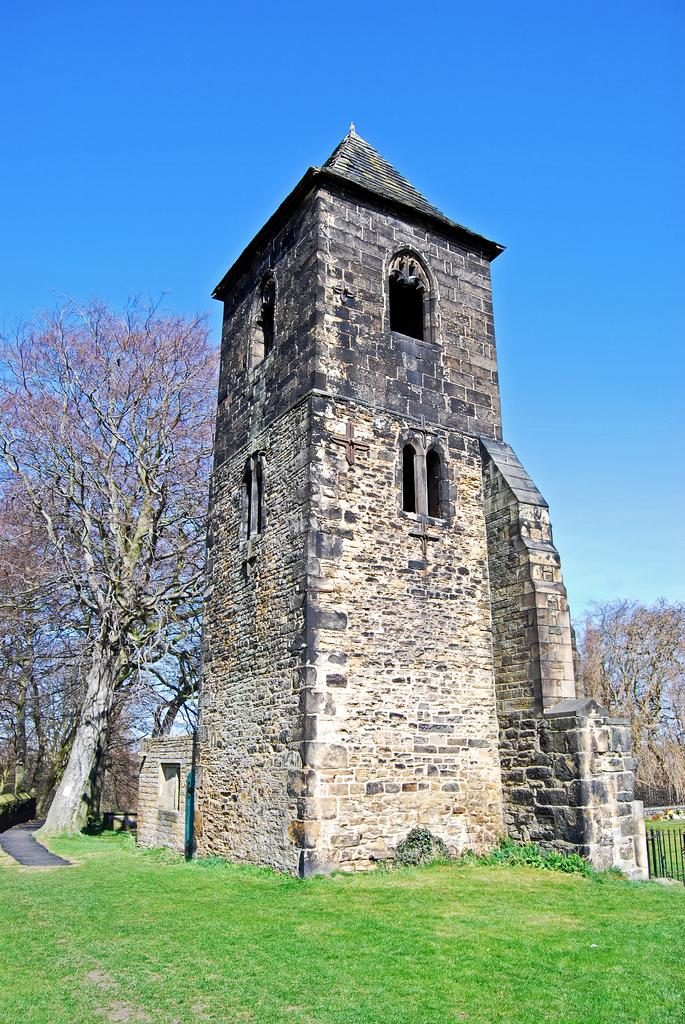What type of house is in the middle of the image? There is a stone house in the middle of the image. What is located near the house? There is a tree beside the house. What can be seen at the top of the image? The sky is visible at the top of the image. What type of ground is present in the image? There is grass on the ground in the image. What type of calculator can be seen on the grass in the image? There is no calculator present in the image; it features a stone house, a tree, the sky, and grass on the ground. 